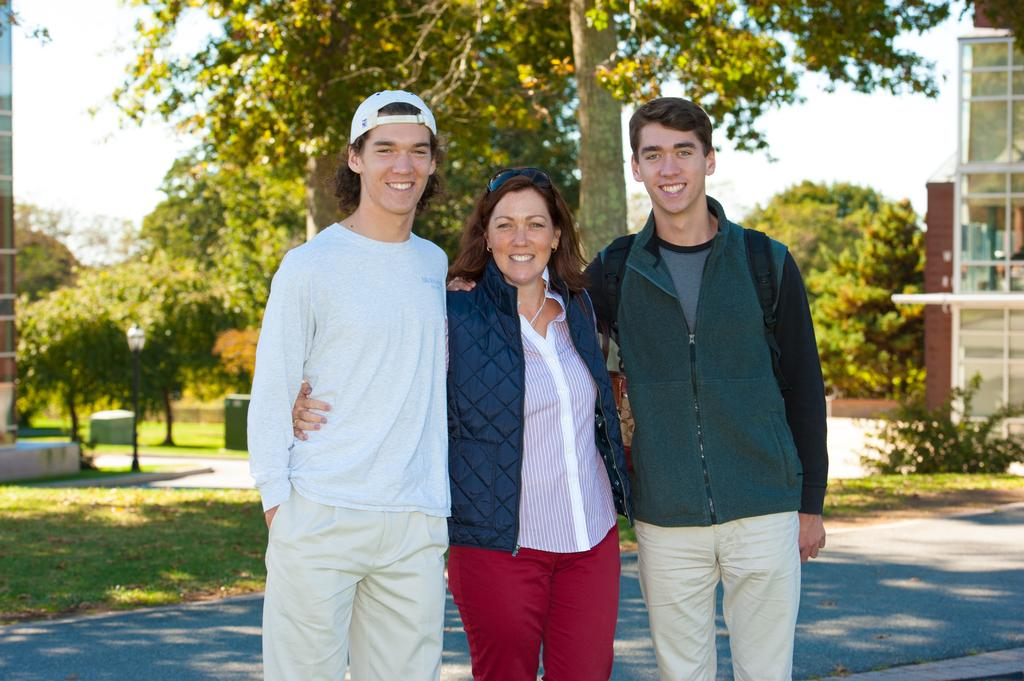How many people are in the image? There are three people standing in the image. What are the people doing in the image? The people are posing for a picture. Can you describe any accessories or clothing items worn by one of the people? One of the people is wearing a bag. What can be seen in the background of the image? Trees, plants, roads, and buildings are visible in the background of the image. What is the rate of the neck in the image? There is no mention of a neck or rate in the image; it features three people posing for a picture with a background of trees, plants, roads, and buildings. 